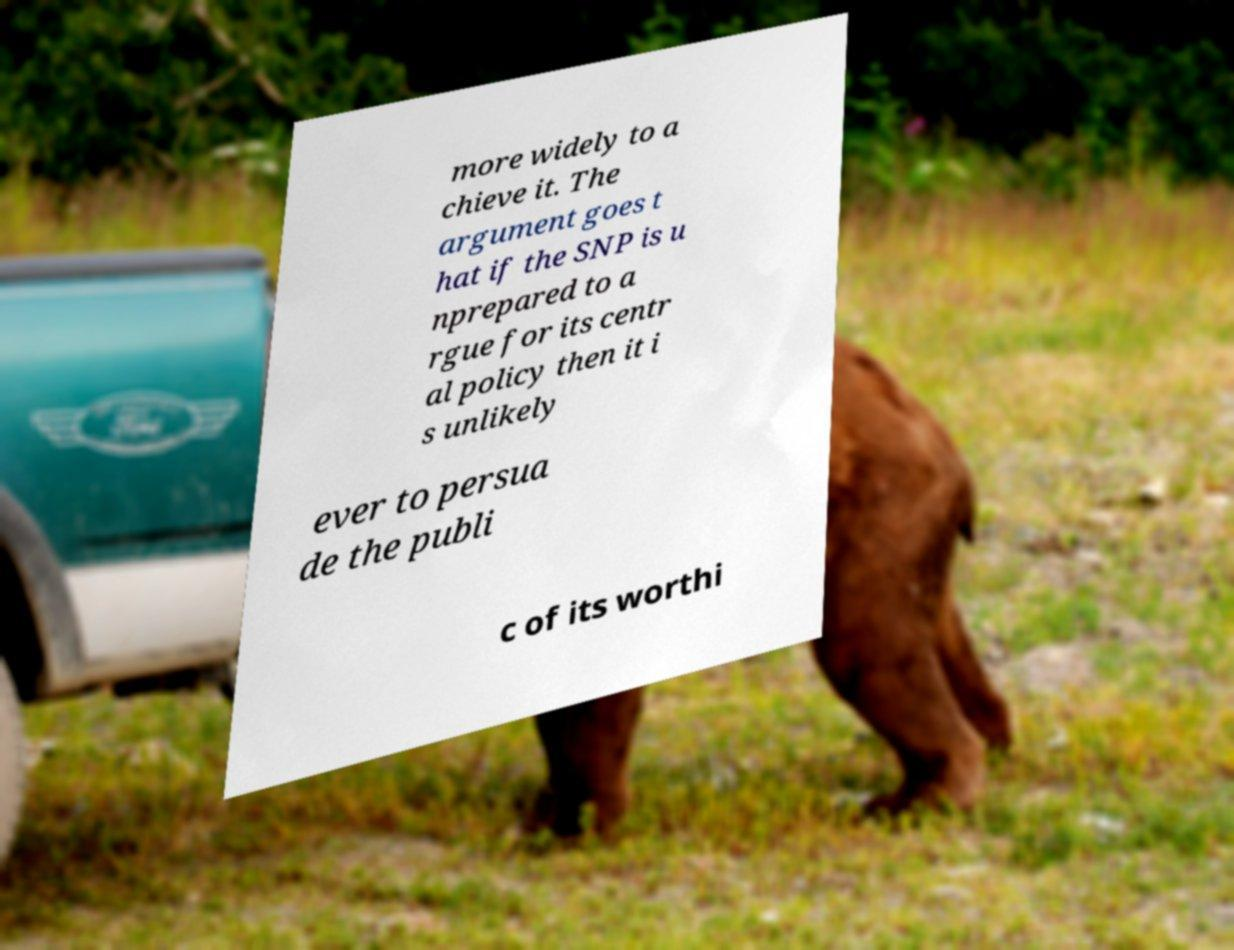Can you read and provide the text displayed in the image?This photo seems to have some interesting text. Can you extract and type it out for me? more widely to a chieve it. The argument goes t hat if the SNP is u nprepared to a rgue for its centr al policy then it i s unlikely ever to persua de the publi c of its worthi 